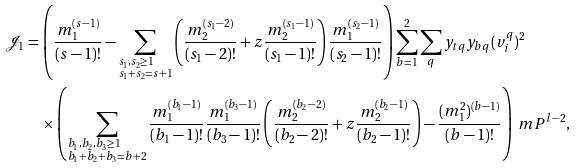<formula> <loc_0><loc_0><loc_500><loc_500>\mathcal { J } _ { 1 } & = \left ( \frac { m _ { 1 } ^ { ( s - 1 ) } } { ( s - 1 ) ! } - \sum _ { \begin{subarray} { c } s _ { 1 } , s _ { 2 } \geq 1 \\ s _ { 1 } + s _ { 2 } = s + 1 \end{subarray} } \left ( \frac { m _ { 2 } ^ { ( s _ { 1 } - 2 ) } } { ( s _ { 1 } - 2 ) ! } + z \frac { m _ { 2 } ^ { ( s _ { 1 } - 1 ) } } { ( s _ { 1 } - 1 ) ! } \right ) \frac { m _ { 1 } ^ { ( s _ { 2 } - 1 ) } } { ( s _ { 2 } - 1 ) ! } \right ) \sum _ { b = 1 } ^ { 2 } \sum _ { q } y _ { t q } y _ { b q } ( v _ { i } ^ { q } ) ^ { 2 } \\ & \quad \times \left ( \sum _ { \begin{subarray} { c } b _ { 1 } , b _ { 2 } , b _ { 3 } \geq 1 \\ b _ { 1 } + b _ { 2 } + b _ { 3 } = b + 2 \end{subarray} } \frac { m _ { 1 } ^ { ( b _ { 1 } - 1 ) } } { ( b _ { 1 } - 1 ) ! } \frac { m _ { 1 } ^ { ( b _ { 3 } - 1 ) } } { ( b _ { 3 } - 1 ) ! } \left ( \frac { m _ { 2 } ^ { ( b _ { 2 } - 2 ) } } { ( b _ { 2 } - 2 ) ! } + z \frac { m _ { 2 } ^ { ( b _ { 2 } - 1 ) } } { ( b _ { 2 } - 1 ) ! } \right ) - \frac { ( m _ { 1 } ^ { 2 } ) ^ { ( b - 1 ) } } { ( b - 1 ) ! } \right ) \ m P ^ { l - 2 } ,</formula> 